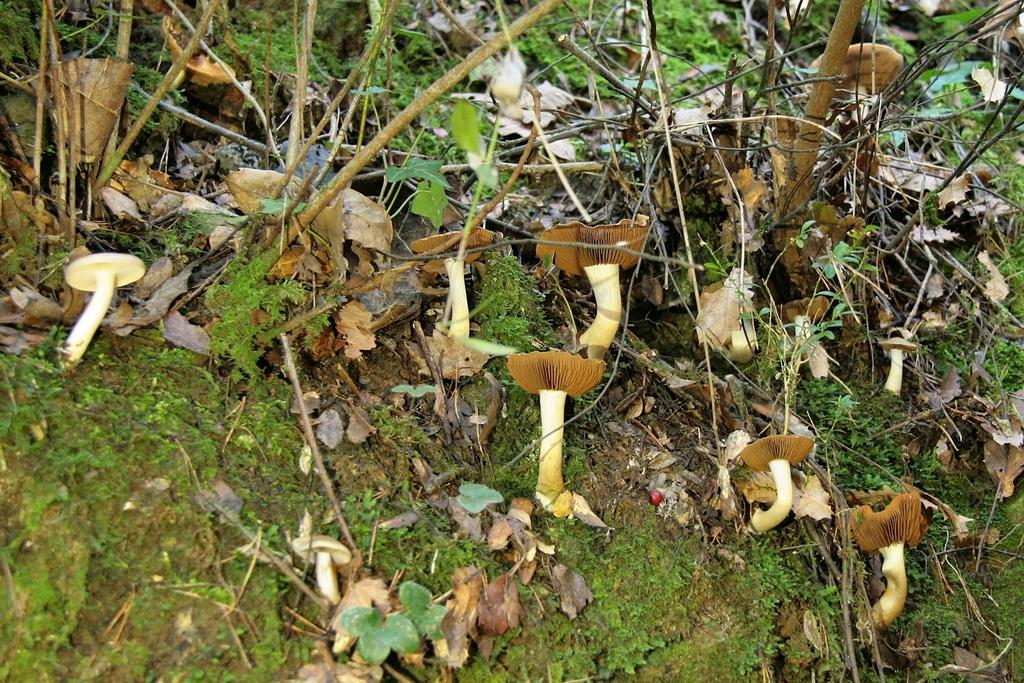What type of vegetation can be seen in the image? There are mushrooms, leaves, and branches in the image. Can you describe the different parts of the vegetation? The mushrooms are round and have a cap, the leaves are flat and green, and the branches are long and have smaller twigs. What color is the rose in the image? There is no rose present in the image; it only contains mushrooms, leaves, and branches. 